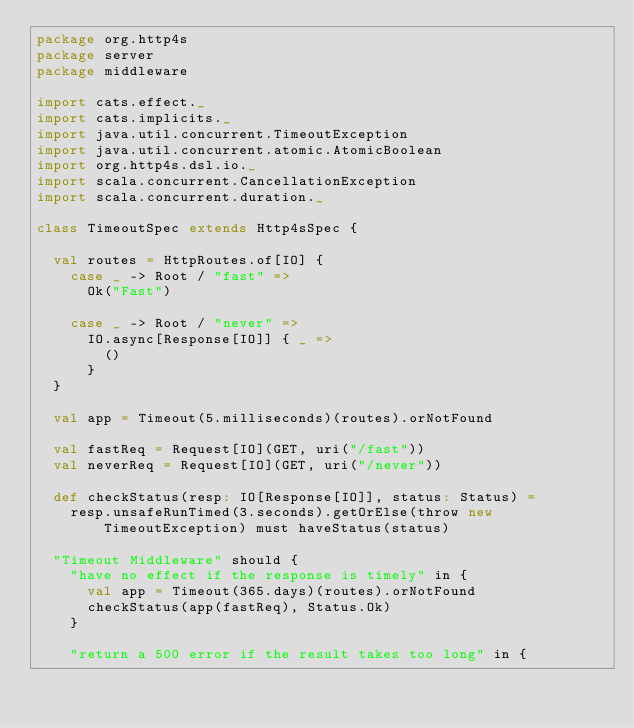Convert code to text. <code><loc_0><loc_0><loc_500><loc_500><_Scala_>package org.http4s
package server
package middleware

import cats.effect._
import cats.implicits._
import java.util.concurrent.TimeoutException
import java.util.concurrent.atomic.AtomicBoolean
import org.http4s.dsl.io._
import scala.concurrent.CancellationException
import scala.concurrent.duration._

class TimeoutSpec extends Http4sSpec {

  val routes = HttpRoutes.of[IO] {
    case _ -> Root / "fast" =>
      Ok("Fast")

    case _ -> Root / "never" =>
      IO.async[Response[IO]] { _ =>
        ()
      }
  }

  val app = Timeout(5.milliseconds)(routes).orNotFound

  val fastReq = Request[IO](GET, uri("/fast"))
  val neverReq = Request[IO](GET, uri("/never"))

  def checkStatus(resp: IO[Response[IO]], status: Status) =
    resp.unsafeRunTimed(3.seconds).getOrElse(throw new TimeoutException) must haveStatus(status)

  "Timeout Middleware" should {
    "have no effect if the response is timely" in {
      val app = Timeout(365.days)(routes).orNotFound
      checkStatus(app(fastReq), Status.Ok)
    }

    "return a 500 error if the result takes too long" in {</code> 